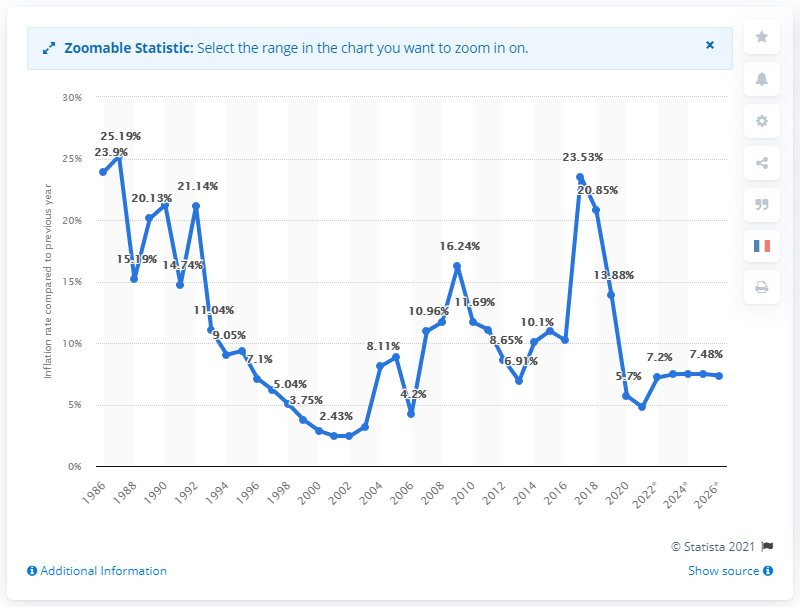Point out several critical features in this image. In 2018, Egypt's inflation rate was 23.53%. In 2018, Egypt's inflation rate was 20.85%. 